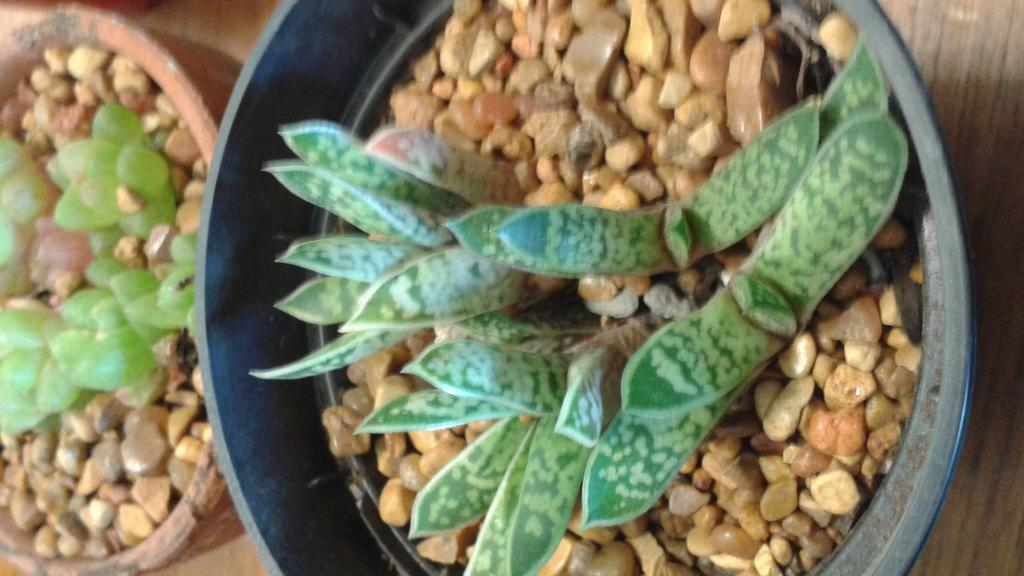How many flower pots can be seen in the image? There are two flower pots in the image. What is inside the flower pots? Houseplants are present in the flower pots. What else can be seen on the floor in the image? Stones are kept on the floor in the image. Can you tell if the image was taken during the day or night? The image was likely taken during the day. What reason does the library have for being in the image? There is no library present in the image; it only features flower pots, houseplants, and stones on the floor. 